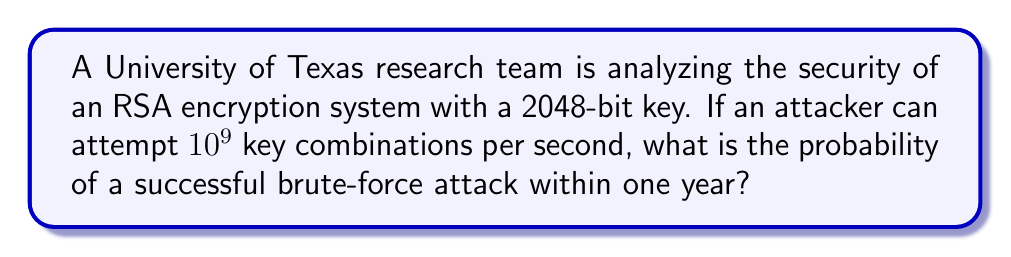Could you help me with this problem? To solve this problem, we need to follow these steps:

1. Calculate the total number of possible keys:
   For a 2048-bit key, the number of possibilities is $2^{2048}$.

2. Calculate the number of attempts possible in one year:
   Attempts per second: $10^9$
   Seconds in a year: $365 \times 24 \times 60 \times 60 = 31,536,000$
   Total attempts in a year: $10^9 \times 31,536,000 = 3.1536 \times 10^{16}$

3. Calculate the probability of success:
   Probability = $\frac{\text{Number of attempts}}{\text{Total number of possibilities}}$

   $$P(\text{success}) = \frac{3.1536 \times 10^{16}}{2^{2048}}$$

4. Simplify the expression:
   $2^{2048} \approx 3.2317 \times 10^{616}$

   $$P(\text{success}) = \frac{3.1536 \times 10^{16}}{3.2317 \times 10^{616}} \approx 9.7584 \times 10^{-601}$$

This probability is extremely small, effectively zero for practical purposes.
Answer: $9.7584 \times 10^{-601}$ 